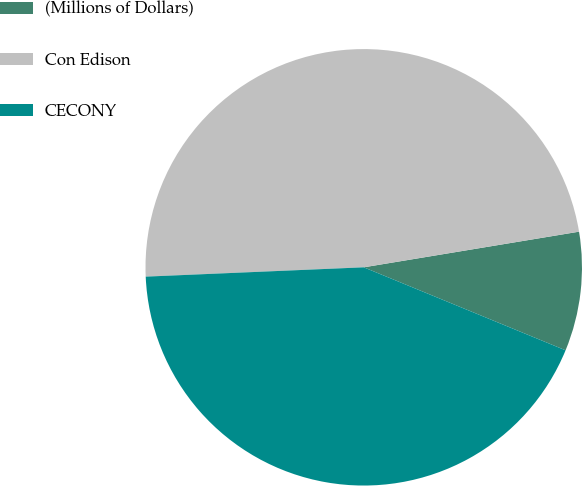Convert chart. <chart><loc_0><loc_0><loc_500><loc_500><pie_chart><fcel>(Millions of Dollars)<fcel>Con Edison<fcel>CECONY<nl><fcel>8.82%<fcel>48.07%<fcel>43.11%<nl></chart> 